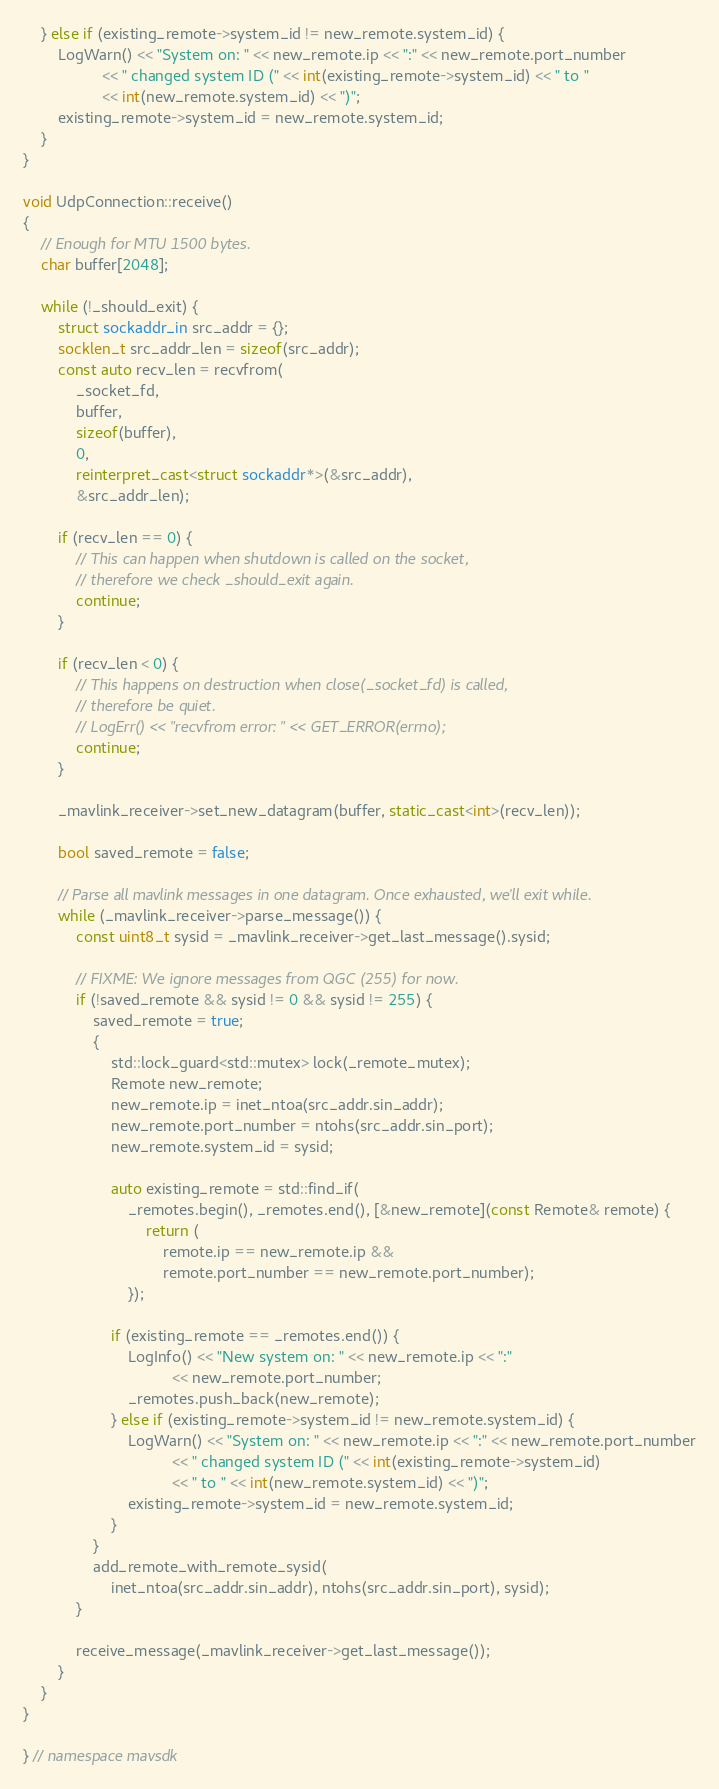<code> <loc_0><loc_0><loc_500><loc_500><_C++_>    } else if (existing_remote->system_id != new_remote.system_id) {
        LogWarn() << "System on: " << new_remote.ip << ":" << new_remote.port_number
                  << " changed system ID (" << int(existing_remote->system_id) << " to "
                  << int(new_remote.system_id) << ")";
        existing_remote->system_id = new_remote.system_id;
    }
}

void UdpConnection::receive()
{
    // Enough for MTU 1500 bytes.
    char buffer[2048];

    while (!_should_exit) {
        struct sockaddr_in src_addr = {};
        socklen_t src_addr_len = sizeof(src_addr);
        const auto recv_len = recvfrom(
            _socket_fd,
            buffer,
            sizeof(buffer),
            0,
            reinterpret_cast<struct sockaddr*>(&src_addr),
            &src_addr_len);

        if (recv_len == 0) {
            // This can happen when shutdown is called on the socket,
            // therefore we check _should_exit again.
            continue;
        }

        if (recv_len < 0) {
            // This happens on destruction when close(_socket_fd) is called,
            // therefore be quiet.
            // LogErr() << "recvfrom error: " << GET_ERROR(errno);
            continue;
        }

        _mavlink_receiver->set_new_datagram(buffer, static_cast<int>(recv_len));

        bool saved_remote = false;

        // Parse all mavlink messages in one datagram. Once exhausted, we'll exit while.
        while (_mavlink_receiver->parse_message()) {
            const uint8_t sysid = _mavlink_receiver->get_last_message().sysid;

            // FIXME: We ignore messages from QGC (255) for now.
            if (!saved_remote && sysid != 0 && sysid != 255) {
                saved_remote = true;
                {
                    std::lock_guard<std::mutex> lock(_remote_mutex);
                    Remote new_remote;
                    new_remote.ip = inet_ntoa(src_addr.sin_addr);
                    new_remote.port_number = ntohs(src_addr.sin_port);
                    new_remote.system_id = sysid;

                    auto existing_remote = std::find_if(
                        _remotes.begin(), _remotes.end(), [&new_remote](const Remote& remote) {
                            return (
                                remote.ip == new_remote.ip &&
                                remote.port_number == new_remote.port_number);
                        });

                    if (existing_remote == _remotes.end()) {
                        LogInfo() << "New system on: " << new_remote.ip << ":"
                                  << new_remote.port_number;
                        _remotes.push_back(new_remote);
                    } else if (existing_remote->system_id != new_remote.system_id) {
                        LogWarn() << "System on: " << new_remote.ip << ":" << new_remote.port_number
                                  << " changed system ID (" << int(existing_remote->system_id)
                                  << " to " << int(new_remote.system_id) << ")";
                        existing_remote->system_id = new_remote.system_id;
                    }
                }
                add_remote_with_remote_sysid(
                    inet_ntoa(src_addr.sin_addr), ntohs(src_addr.sin_port), sysid);
            }

            receive_message(_mavlink_receiver->get_last_message());
        }
    }
}

} // namespace mavsdk
</code> 